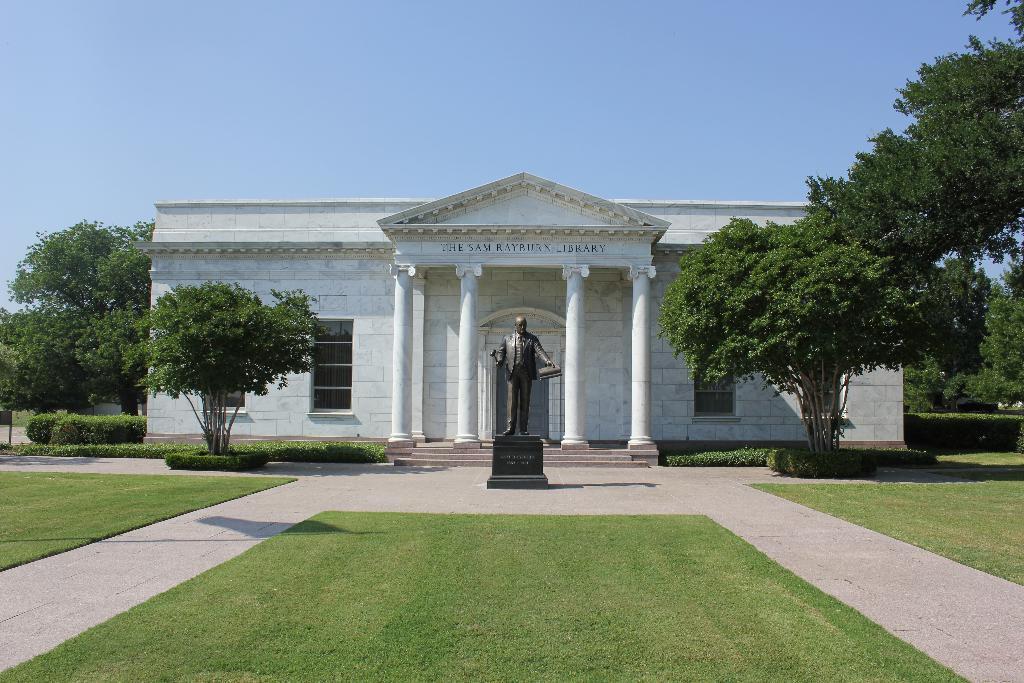Can you describe this image briefly? There is a statue of a man in front of the white building. The white building has the four pillars in front of its entrance. The name of the white building is the sam rayburn library. Yes and it's a library. There is a window for this building. In Front of this library there is a lawn. Besides this lawn there is a path towards the library. There are some trees around the library and plants also located. We can observe a sky in the background. 